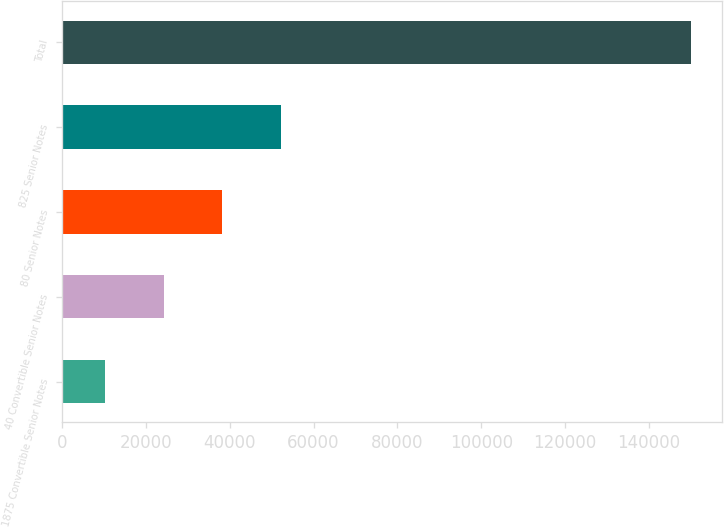Convert chart to OTSL. <chart><loc_0><loc_0><loc_500><loc_500><bar_chart><fcel>1875 Convertible Senior Notes<fcel>40 Convertible Senior Notes<fcel>80 Senior Notes<fcel>825 Senior Notes<fcel>Total<nl><fcel>10313<fcel>24273.8<fcel>38234.6<fcel>52195.4<fcel>149921<nl></chart> 